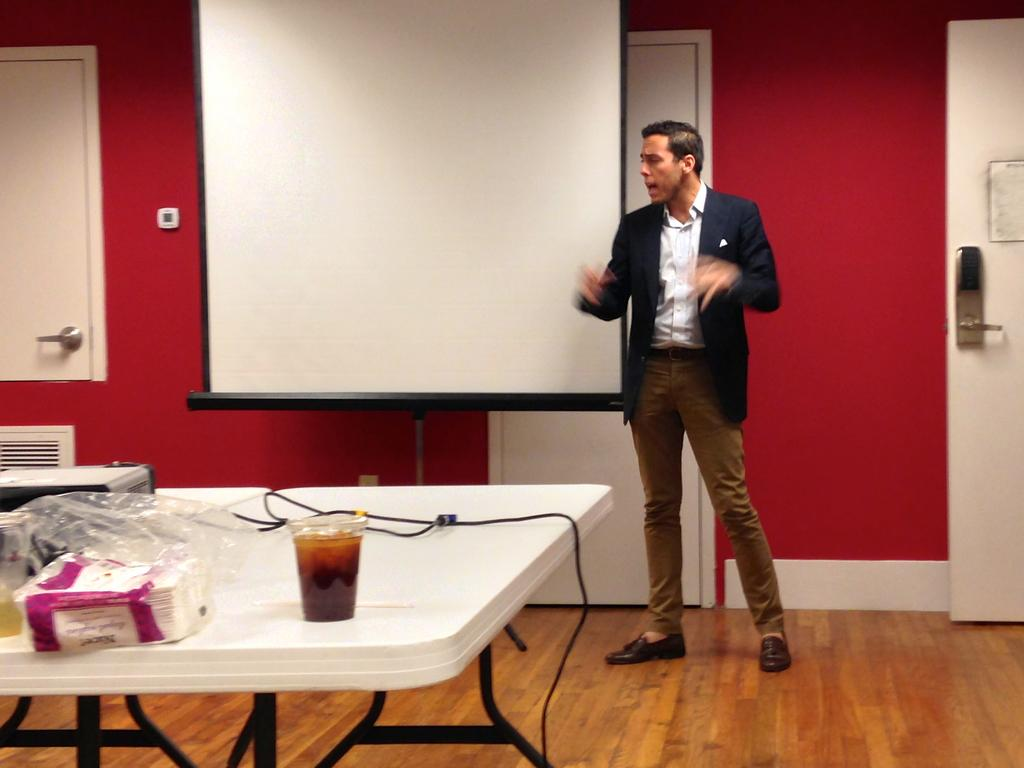What is the main subject in the image? There is a person standing in the image. What object can be seen near the person? There is a table in the image. What is on the table? There is a glass and tissues on the table. What is the large, flat surface in the image? There is a projector screen in the image. What type of government is depicted on the projector screen in the image? There is no government depicted on the projector screen in the image; it is a large, flat surface used for displaying images or videos. 